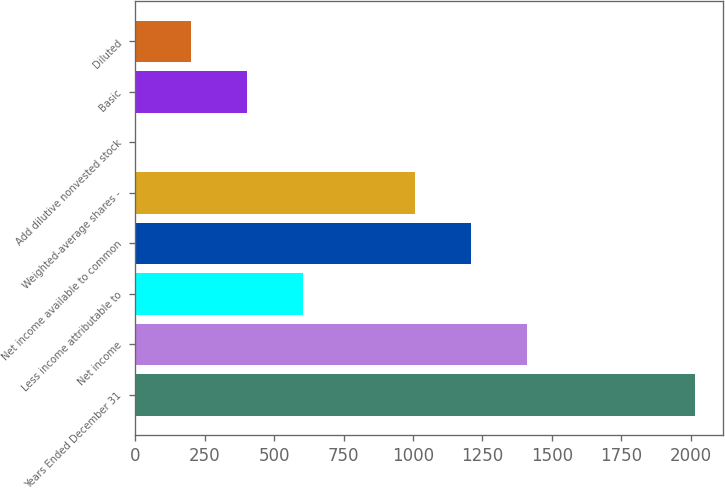Convert chart to OTSL. <chart><loc_0><loc_0><loc_500><loc_500><bar_chart><fcel>Years Ended December 31<fcel>Net income<fcel>Less income attributable to<fcel>Net income available to common<fcel>Weighted-average shares -<fcel>Add dilutive nonvested stock<fcel>Basic<fcel>Diluted<nl><fcel>2015<fcel>1410.77<fcel>605.13<fcel>1209.36<fcel>1007.95<fcel>0.9<fcel>403.72<fcel>202.31<nl></chart> 